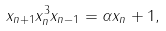Convert formula to latex. <formula><loc_0><loc_0><loc_500><loc_500>x _ { n + 1 } x _ { n } ^ { 3 } x _ { n - 1 } = \alpha x _ { n } + 1 ,</formula> 